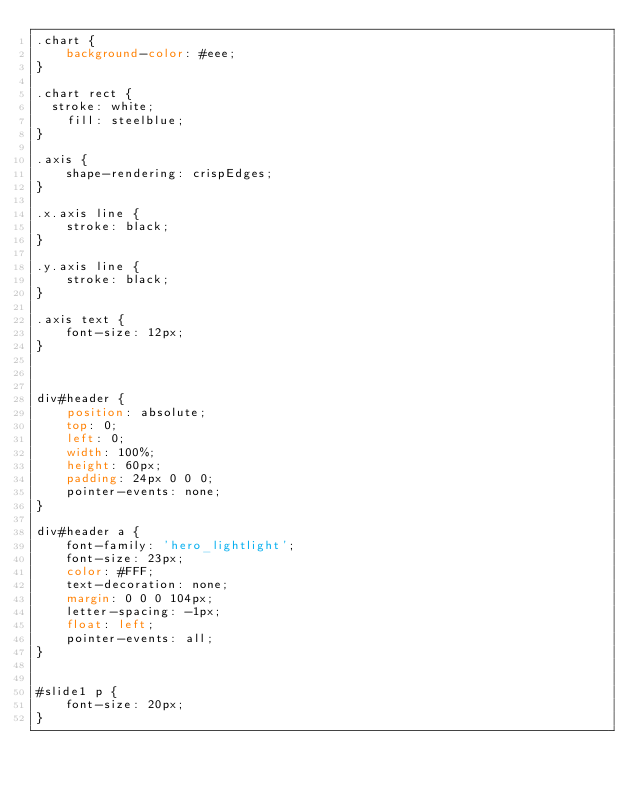<code> <loc_0><loc_0><loc_500><loc_500><_CSS_>.chart {
    background-color: #eee;
}

.chart rect {
	stroke: white;
    fill: steelblue;
}

.axis {
    shape-rendering: crispEdges;
}

.x.axis line {
    stroke: black;
}

.y.axis line {
    stroke: black;
}

.axis text {
    font-size: 12px;
}



div#header {
    position: absolute;
    top: 0;
    left: 0;
    width: 100%;
    height: 60px;
    padding: 24px 0 0 0;
    pointer-events: none;
}

div#header a {
    font-family: 'hero_lightlight';
    font-size: 23px;
    color: #FFF;
    text-decoration: none;
    margin: 0 0 0 104px;
    letter-spacing: -1px;
    float: left;
    pointer-events: all;
}


#slide1 p {
    font-size: 20px;
}</code> 